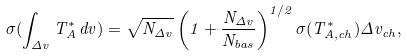Convert formula to latex. <formula><loc_0><loc_0><loc_500><loc_500>\sigma ( \int _ { \Delta v } T ^ { * } _ { A } \, d v ) = \sqrt { N _ { \Delta v } } \left ( 1 + \frac { N _ { \Delta v } } { N _ { b a s } } \right ) ^ { 1 / 2 } \sigma ( T ^ { * } _ { A , c h } ) \Delta v _ { c h } ,</formula> 